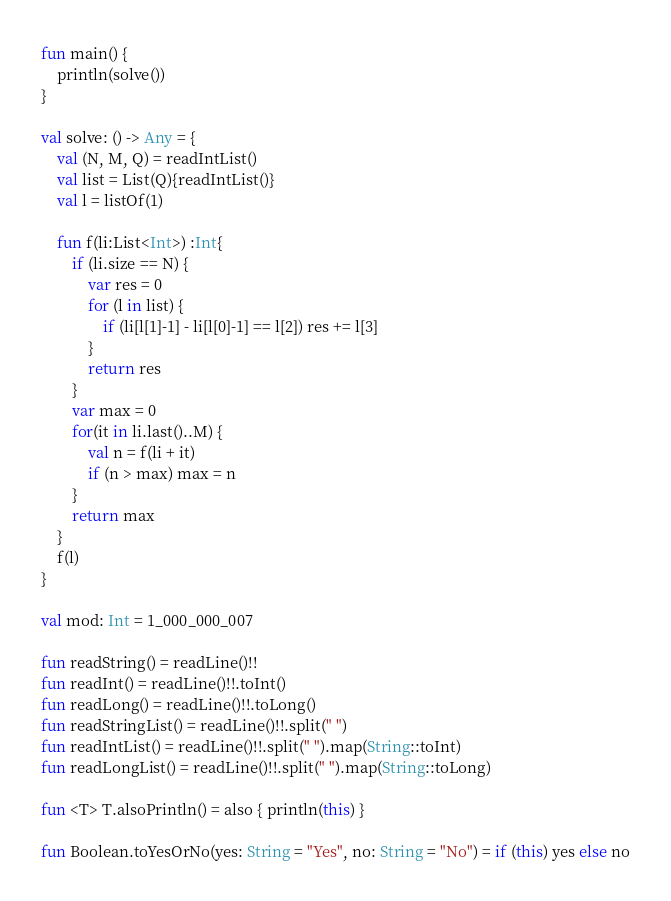<code> <loc_0><loc_0><loc_500><loc_500><_Kotlin_>fun main() {
    println(solve())
}

val solve: () -> Any = {
    val (N, M, Q) = readIntList()
    val list = List(Q){readIntList()}
    val l = listOf(1)

    fun f(li:List<Int>) :Int{
        if (li.size == N) {
            var res = 0
            for (l in list) {
                if (li[l[1]-1] - li[l[0]-1] == l[2]) res += l[3]
            }
            return res
        }
        var max = 0
        for(it in li.last()..M) {
            val n = f(li + it)
            if (n > max) max = n
        }
        return max
    }
    f(l)
}

val mod: Int = 1_000_000_007

fun readString() = readLine()!!
fun readInt() = readLine()!!.toInt()
fun readLong() = readLine()!!.toLong()
fun readStringList() = readLine()!!.split(" ")
fun readIntList() = readLine()!!.split(" ").map(String::toInt)
fun readLongList() = readLine()!!.split(" ").map(String::toLong)

fun <T> T.alsoPrintln() = also { println(this) }

fun Boolean.toYesOrNo(yes: String = "Yes", no: String = "No") = if (this) yes else no</code> 